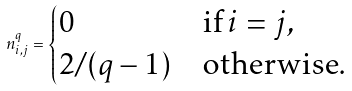Convert formula to latex. <formula><loc_0><loc_0><loc_500><loc_500>n _ { i , j } ^ { q } = \begin{cases} 0 & \text {if} \, i = j , \\ 2 / ( q - 1 ) & \text {otherwise} . \end{cases}</formula> 